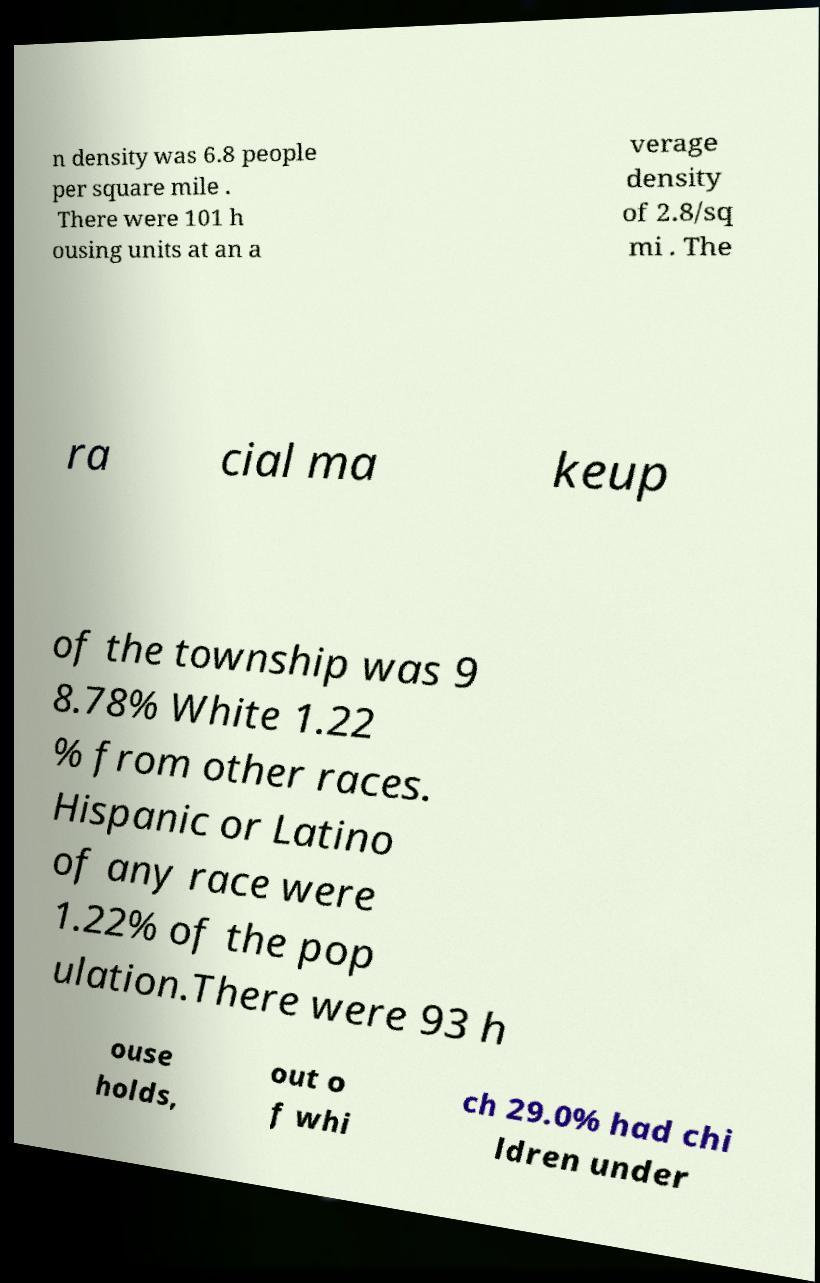Could you assist in decoding the text presented in this image and type it out clearly? n density was 6.8 people per square mile . There were 101 h ousing units at an a verage density of 2.8/sq mi . The ra cial ma keup of the township was 9 8.78% White 1.22 % from other races. Hispanic or Latino of any race were 1.22% of the pop ulation.There were 93 h ouse holds, out o f whi ch 29.0% had chi ldren under 